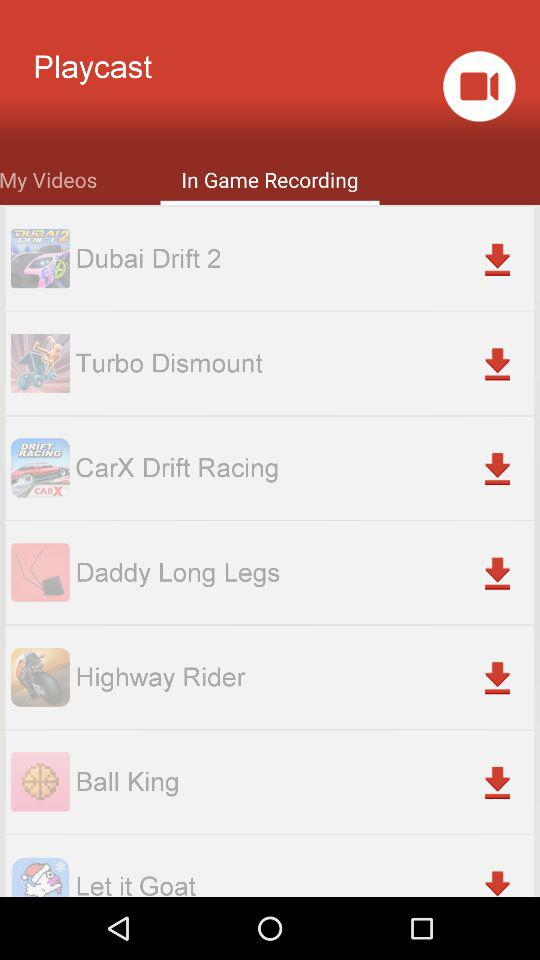What is the application name? The application name is "Playcast". 